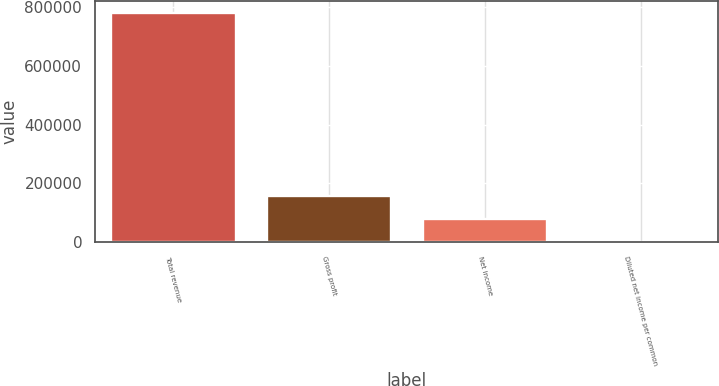<chart> <loc_0><loc_0><loc_500><loc_500><bar_chart><fcel>Total revenue<fcel>Gross profit<fcel>Net income<fcel>Diluted net income per common<nl><fcel>782171<fcel>156434<fcel>78217.3<fcel>0.2<nl></chart> 